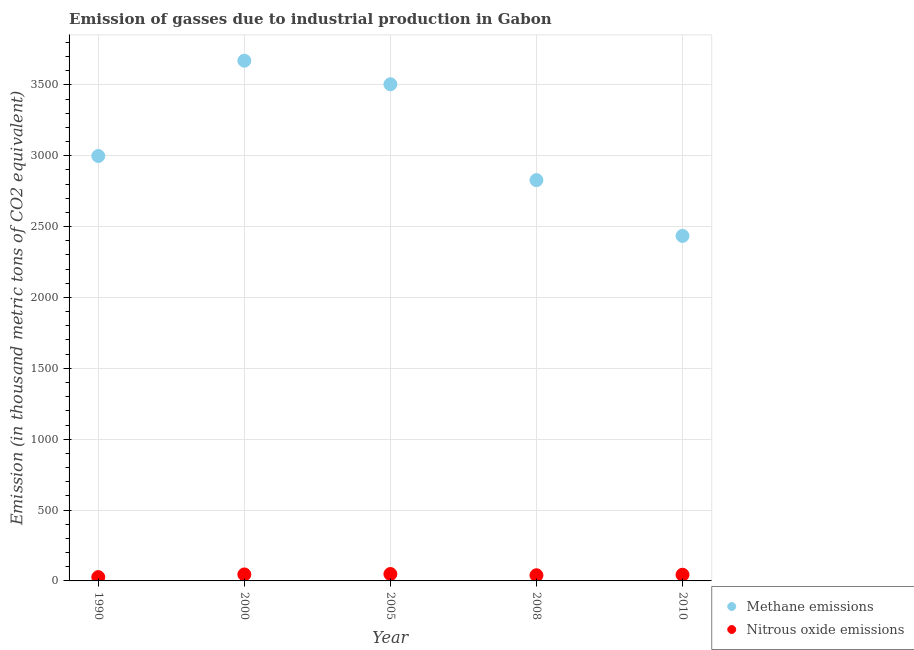Is the number of dotlines equal to the number of legend labels?
Your answer should be very brief. Yes. What is the amount of nitrous oxide emissions in 1990?
Your answer should be very brief. 26.7. Across all years, what is the maximum amount of nitrous oxide emissions?
Provide a succinct answer. 48.7. Across all years, what is the minimum amount of nitrous oxide emissions?
Provide a succinct answer. 26.7. In which year was the amount of methane emissions minimum?
Give a very brief answer. 2010. What is the total amount of nitrous oxide emissions in the graph?
Offer a terse response. 204.9. What is the difference between the amount of methane emissions in 2008 and that in 2010?
Your answer should be compact. 393.6. What is the difference between the amount of nitrous oxide emissions in 1990 and the amount of methane emissions in 2000?
Your answer should be very brief. -3644. What is the average amount of nitrous oxide emissions per year?
Provide a succinct answer. 40.98. In the year 2010, what is the difference between the amount of nitrous oxide emissions and amount of methane emissions?
Offer a terse response. -2390.8. What is the ratio of the amount of nitrous oxide emissions in 2000 to that in 2010?
Provide a succinct answer. 1.05. Is the amount of nitrous oxide emissions in 2005 less than that in 2008?
Give a very brief answer. No. Is the difference between the amount of methane emissions in 1990 and 2008 greater than the difference between the amount of nitrous oxide emissions in 1990 and 2008?
Keep it short and to the point. Yes. What is the difference between the highest and the second highest amount of methane emissions?
Make the answer very short. 166.2. What is the difference between the highest and the lowest amount of methane emissions?
Give a very brief answer. 1236.3. In how many years, is the amount of nitrous oxide emissions greater than the average amount of nitrous oxide emissions taken over all years?
Provide a succinct answer. 3. Is the sum of the amount of nitrous oxide emissions in 1990 and 2005 greater than the maximum amount of methane emissions across all years?
Give a very brief answer. No. Is the amount of nitrous oxide emissions strictly less than the amount of methane emissions over the years?
Offer a very short reply. Yes. How many dotlines are there?
Provide a short and direct response. 2. How many years are there in the graph?
Offer a very short reply. 5. What is the difference between two consecutive major ticks on the Y-axis?
Your answer should be very brief. 500. Where does the legend appear in the graph?
Offer a terse response. Bottom right. How many legend labels are there?
Give a very brief answer. 2. What is the title of the graph?
Keep it short and to the point. Emission of gasses due to industrial production in Gabon. Does "IMF concessional" appear as one of the legend labels in the graph?
Keep it short and to the point. No. What is the label or title of the Y-axis?
Ensure brevity in your answer.  Emission (in thousand metric tons of CO2 equivalent). What is the Emission (in thousand metric tons of CO2 equivalent) of Methane emissions in 1990?
Ensure brevity in your answer.  2998.2. What is the Emission (in thousand metric tons of CO2 equivalent) of Nitrous oxide emissions in 1990?
Your answer should be compact. 26.7. What is the Emission (in thousand metric tons of CO2 equivalent) in Methane emissions in 2000?
Your answer should be compact. 3670.7. What is the Emission (in thousand metric tons of CO2 equivalent) in Nitrous oxide emissions in 2000?
Provide a short and direct response. 45.8. What is the Emission (in thousand metric tons of CO2 equivalent) of Methane emissions in 2005?
Offer a very short reply. 3504.5. What is the Emission (in thousand metric tons of CO2 equivalent) in Nitrous oxide emissions in 2005?
Offer a terse response. 48.7. What is the Emission (in thousand metric tons of CO2 equivalent) in Methane emissions in 2008?
Make the answer very short. 2828. What is the Emission (in thousand metric tons of CO2 equivalent) of Nitrous oxide emissions in 2008?
Your response must be concise. 40.1. What is the Emission (in thousand metric tons of CO2 equivalent) in Methane emissions in 2010?
Offer a very short reply. 2434.4. What is the Emission (in thousand metric tons of CO2 equivalent) in Nitrous oxide emissions in 2010?
Your response must be concise. 43.6. Across all years, what is the maximum Emission (in thousand metric tons of CO2 equivalent) in Methane emissions?
Offer a very short reply. 3670.7. Across all years, what is the maximum Emission (in thousand metric tons of CO2 equivalent) of Nitrous oxide emissions?
Your answer should be very brief. 48.7. Across all years, what is the minimum Emission (in thousand metric tons of CO2 equivalent) of Methane emissions?
Keep it short and to the point. 2434.4. Across all years, what is the minimum Emission (in thousand metric tons of CO2 equivalent) of Nitrous oxide emissions?
Your answer should be very brief. 26.7. What is the total Emission (in thousand metric tons of CO2 equivalent) in Methane emissions in the graph?
Give a very brief answer. 1.54e+04. What is the total Emission (in thousand metric tons of CO2 equivalent) in Nitrous oxide emissions in the graph?
Your answer should be compact. 204.9. What is the difference between the Emission (in thousand metric tons of CO2 equivalent) of Methane emissions in 1990 and that in 2000?
Your answer should be compact. -672.5. What is the difference between the Emission (in thousand metric tons of CO2 equivalent) of Nitrous oxide emissions in 1990 and that in 2000?
Your answer should be compact. -19.1. What is the difference between the Emission (in thousand metric tons of CO2 equivalent) of Methane emissions in 1990 and that in 2005?
Provide a succinct answer. -506.3. What is the difference between the Emission (in thousand metric tons of CO2 equivalent) in Methane emissions in 1990 and that in 2008?
Give a very brief answer. 170.2. What is the difference between the Emission (in thousand metric tons of CO2 equivalent) of Nitrous oxide emissions in 1990 and that in 2008?
Provide a short and direct response. -13.4. What is the difference between the Emission (in thousand metric tons of CO2 equivalent) of Methane emissions in 1990 and that in 2010?
Make the answer very short. 563.8. What is the difference between the Emission (in thousand metric tons of CO2 equivalent) of Nitrous oxide emissions in 1990 and that in 2010?
Provide a succinct answer. -16.9. What is the difference between the Emission (in thousand metric tons of CO2 equivalent) in Methane emissions in 2000 and that in 2005?
Offer a very short reply. 166.2. What is the difference between the Emission (in thousand metric tons of CO2 equivalent) of Nitrous oxide emissions in 2000 and that in 2005?
Keep it short and to the point. -2.9. What is the difference between the Emission (in thousand metric tons of CO2 equivalent) of Methane emissions in 2000 and that in 2008?
Offer a terse response. 842.7. What is the difference between the Emission (in thousand metric tons of CO2 equivalent) in Methane emissions in 2000 and that in 2010?
Give a very brief answer. 1236.3. What is the difference between the Emission (in thousand metric tons of CO2 equivalent) in Nitrous oxide emissions in 2000 and that in 2010?
Your answer should be very brief. 2.2. What is the difference between the Emission (in thousand metric tons of CO2 equivalent) in Methane emissions in 2005 and that in 2008?
Keep it short and to the point. 676.5. What is the difference between the Emission (in thousand metric tons of CO2 equivalent) in Methane emissions in 2005 and that in 2010?
Your answer should be very brief. 1070.1. What is the difference between the Emission (in thousand metric tons of CO2 equivalent) of Methane emissions in 2008 and that in 2010?
Offer a terse response. 393.6. What is the difference between the Emission (in thousand metric tons of CO2 equivalent) of Nitrous oxide emissions in 2008 and that in 2010?
Provide a short and direct response. -3.5. What is the difference between the Emission (in thousand metric tons of CO2 equivalent) of Methane emissions in 1990 and the Emission (in thousand metric tons of CO2 equivalent) of Nitrous oxide emissions in 2000?
Ensure brevity in your answer.  2952.4. What is the difference between the Emission (in thousand metric tons of CO2 equivalent) in Methane emissions in 1990 and the Emission (in thousand metric tons of CO2 equivalent) in Nitrous oxide emissions in 2005?
Offer a very short reply. 2949.5. What is the difference between the Emission (in thousand metric tons of CO2 equivalent) in Methane emissions in 1990 and the Emission (in thousand metric tons of CO2 equivalent) in Nitrous oxide emissions in 2008?
Give a very brief answer. 2958.1. What is the difference between the Emission (in thousand metric tons of CO2 equivalent) of Methane emissions in 1990 and the Emission (in thousand metric tons of CO2 equivalent) of Nitrous oxide emissions in 2010?
Your response must be concise. 2954.6. What is the difference between the Emission (in thousand metric tons of CO2 equivalent) in Methane emissions in 2000 and the Emission (in thousand metric tons of CO2 equivalent) in Nitrous oxide emissions in 2005?
Offer a very short reply. 3622. What is the difference between the Emission (in thousand metric tons of CO2 equivalent) of Methane emissions in 2000 and the Emission (in thousand metric tons of CO2 equivalent) of Nitrous oxide emissions in 2008?
Give a very brief answer. 3630.6. What is the difference between the Emission (in thousand metric tons of CO2 equivalent) in Methane emissions in 2000 and the Emission (in thousand metric tons of CO2 equivalent) in Nitrous oxide emissions in 2010?
Keep it short and to the point. 3627.1. What is the difference between the Emission (in thousand metric tons of CO2 equivalent) in Methane emissions in 2005 and the Emission (in thousand metric tons of CO2 equivalent) in Nitrous oxide emissions in 2008?
Your response must be concise. 3464.4. What is the difference between the Emission (in thousand metric tons of CO2 equivalent) in Methane emissions in 2005 and the Emission (in thousand metric tons of CO2 equivalent) in Nitrous oxide emissions in 2010?
Provide a short and direct response. 3460.9. What is the difference between the Emission (in thousand metric tons of CO2 equivalent) in Methane emissions in 2008 and the Emission (in thousand metric tons of CO2 equivalent) in Nitrous oxide emissions in 2010?
Offer a terse response. 2784.4. What is the average Emission (in thousand metric tons of CO2 equivalent) of Methane emissions per year?
Make the answer very short. 3087.16. What is the average Emission (in thousand metric tons of CO2 equivalent) of Nitrous oxide emissions per year?
Give a very brief answer. 40.98. In the year 1990, what is the difference between the Emission (in thousand metric tons of CO2 equivalent) in Methane emissions and Emission (in thousand metric tons of CO2 equivalent) in Nitrous oxide emissions?
Provide a short and direct response. 2971.5. In the year 2000, what is the difference between the Emission (in thousand metric tons of CO2 equivalent) of Methane emissions and Emission (in thousand metric tons of CO2 equivalent) of Nitrous oxide emissions?
Offer a very short reply. 3624.9. In the year 2005, what is the difference between the Emission (in thousand metric tons of CO2 equivalent) in Methane emissions and Emission (in thousand metric tons of CO2 equivalent) in Nitrous oxide emissions?
Make the answer very short. 3455.8. In the year 2008, what is the difference between the Emission (in thousand metric tons of CO2 equivalent) in Methane emissions and Emission (in thousand metric tons of CO2 equivalent) in Nitrous oxide emissions?
Provide a succinct answer. 2787.9. In the year 2010, what is the difference between the Emission (in thousand metric tons of CO2 equivalent) of Methane emissions and Emission (in thousand metric tons of CO2 equivalent) of Nitrous oxide emissions?
Your response must be concise. 2390.8. What is the ratio of the Emission (in thousand metric tons of CO2 equivalent) in Methane emissions in 1990 to that in 2000?
Keep it short and to the point. 0.82. What is the ratio of the Emission (in thousand metric tons of CO2 equivalent) in Nitrous oxide emissions in 1990 to that in 2000?
Offer a terse response. 0.58. What is the ratio of the Emission (in thousand metric tons of CO2 equivalent) of Methane emissions in 1990 to that in 2005?
Ensure brevity in your answer.  0.86. What is the ratio of the Emission (in thousand metric tons of CO2 equivalent) of Nitrous oxide emissions in 1990 to that in 2005?
Offer a very short reply. 0.55. What is the ratio of the Emission (in thousand metric tons of CO2 equivalent) of Methane emissions in 1990 to that in 2008?
Your answer should be compact. 1.06. What is the ratio of the Emission (in thousand metric tons of CO2 equivalent) in Nitrous oxide emissions in 1990 to that in 2008?
Your answer should be compact. 0.67. What is the ratio of the Emission (in thousand metric tons of CO2 equivalent) in Methane emissions in 1990 to that in 2010?
Offer a very short reply. 1.23. What is the ratio of the Emission (in thousand metric tons of CO2 equivalent) in Nitrous oxide emissions in 1990 to that in 2010?
Give a very brief answer. 0.61. What is the ratio of the Emission (in thousand metric tons of CO2 equivalent) of Methane emissions in 2000 to that in 2005?
Your answer should be very brief. 1.05. What is the ratio of the Emission (in thousand metric tons of CO2 equivalent) in Nitrous oxide emissions in 2000 to that in 2005?
Make the answer very short. 0.94. What is the ratio of the Emission (in thousand metric tons of CO2 equivalent) of Methane emissions in 2000 to that in 2008?
Offer a very short reply. 1.3. What is the ratio of the Emission (in thousand metric tons of CO2 equivalent) in Nitrous oxide emissions in 2000 to that in 2008?
Your answer should be very brief. 1.14. What is the ratio of the Emission (in thousand metric tons of CO2 equivalent) in Methane emissions in 2000 to that in 2010?
Your answer should be compact. 1.51. What is the ratio of the Emission (in thousand metric tons of CO2 equivalent) in Nitrous oxide emissions in 2000 to that in 2010?
Offer a terse response. 1.05. What is the ratio of the Emission (in thousand metric tons of CO2 equivalent) of Methane emissions in 2005 to that in 2008?
Offer a very short reply. 1.24. What is the ratio of the Emission (in thousand metric tons of CO2 equivalent) of Nitrous oxide emissions in 2005 to that in 2008?
Offer a terse response. 1.21. What is the ratio of the Emission (in thousand metric tons of CO2 equivalent) of Methane emissions in 2005 to that in 2010?
Your answer should be very brief. 1.44. What is the ratio of the Emission (in thousand metric tons of CO2 equivalent) in Nitrous oxide emissions in 2005 to that in 2010?
Give a very brief answer. 1.12. What is the ratio of the Emission (in thousand metric tons of CO2 equivalent) of Methane emissions in 2008 to that in 2010?
Your response must be concise. 1.16. What is the ratio of the Emission (in thousand metric tons of CO2 equivalent) of Nitrous oxide emissions in 2008 to that in 2010?
Provide a short and direct response. 0.92. What is the difference between the highest and the second highest Emission (in thousand metric tons of CO2 equivalent) in Methane emissions?
Your response must be concise. 166.2. What is the difference between the highest and the second highest Emission (in thousand metric tons of CO2 equivalent) of Nitrous oxide emissions?
Your answer should be compact. 2.9. What is the difference between the highest and the lowest Emission (in thousand metric tons of CO2 equivalent) in Methane emissions?
Your answer should be compact. 1236.3. What is the difference between the highest and the lowest Emission (in thousand metric tons of CO2 equivalent) of Nitrous oxide emissions?
Your response must be concise. 22. 